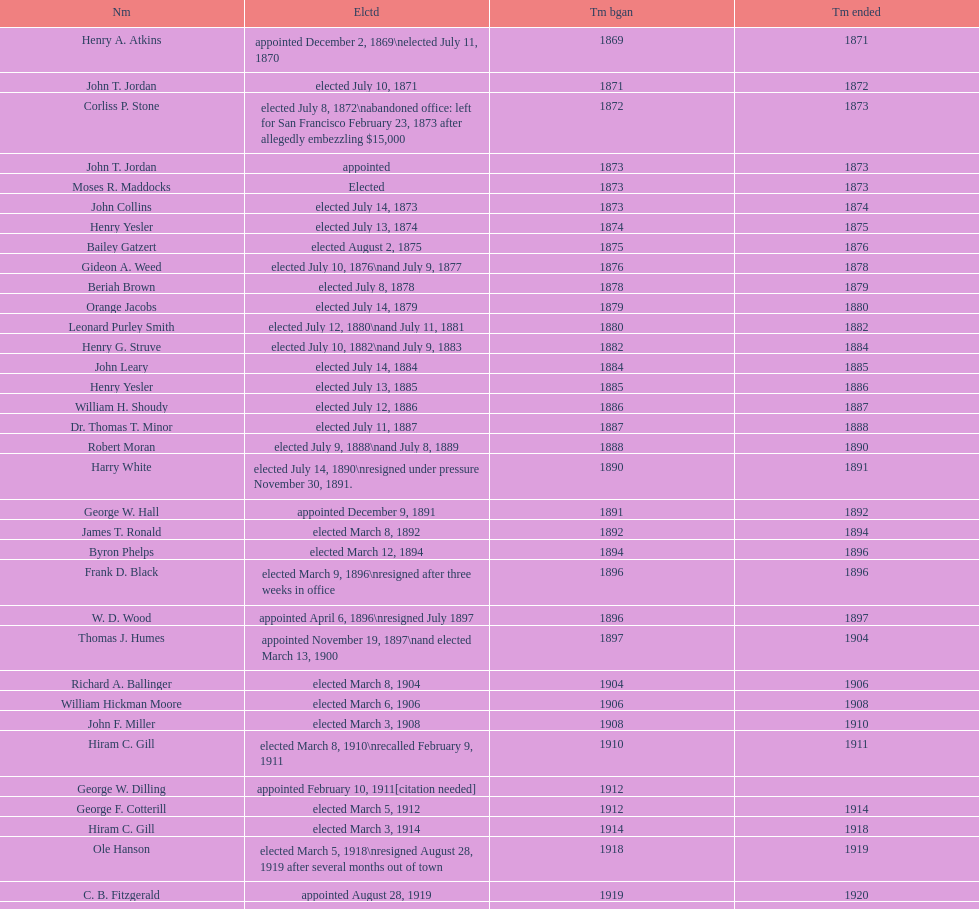How many days did robert moran serve? 365. 